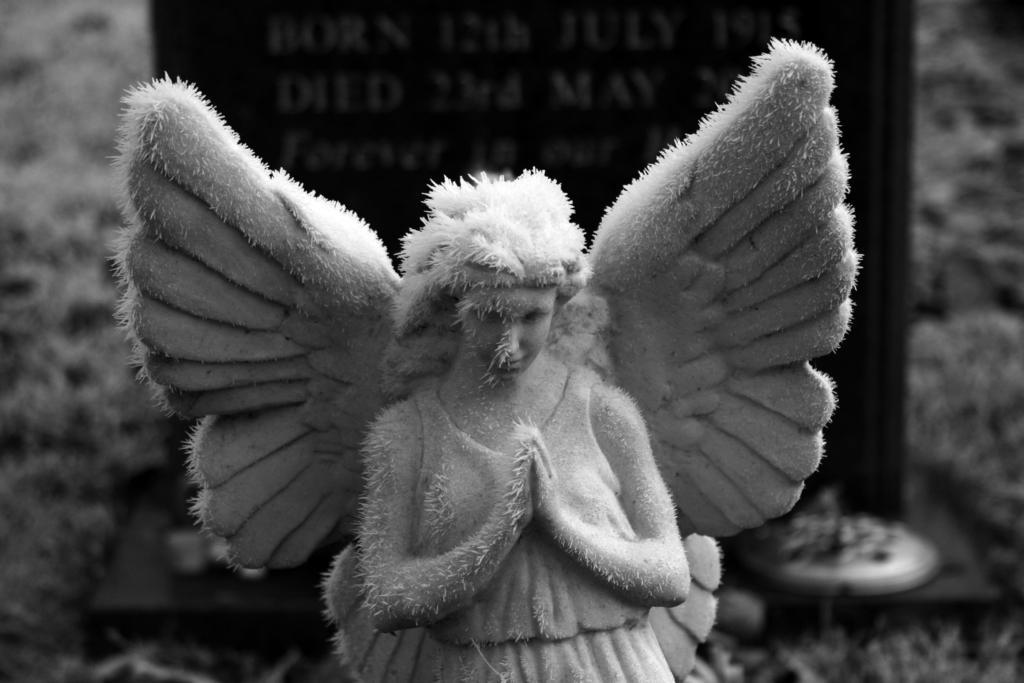Can you describe this image briefly? This is a black and white image. In this image we can see a statue. On the backside we can see a board with some text on it. 